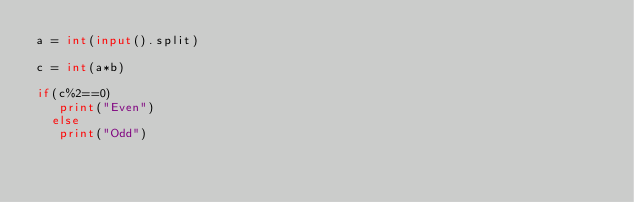<code> <loc_0><loc_0><loc_500><loc_500><_Python_>a = int(input().split)

c = int(a*b)

if(c%2==0)
   print("Even")
  else
   print("Odd")</code> 